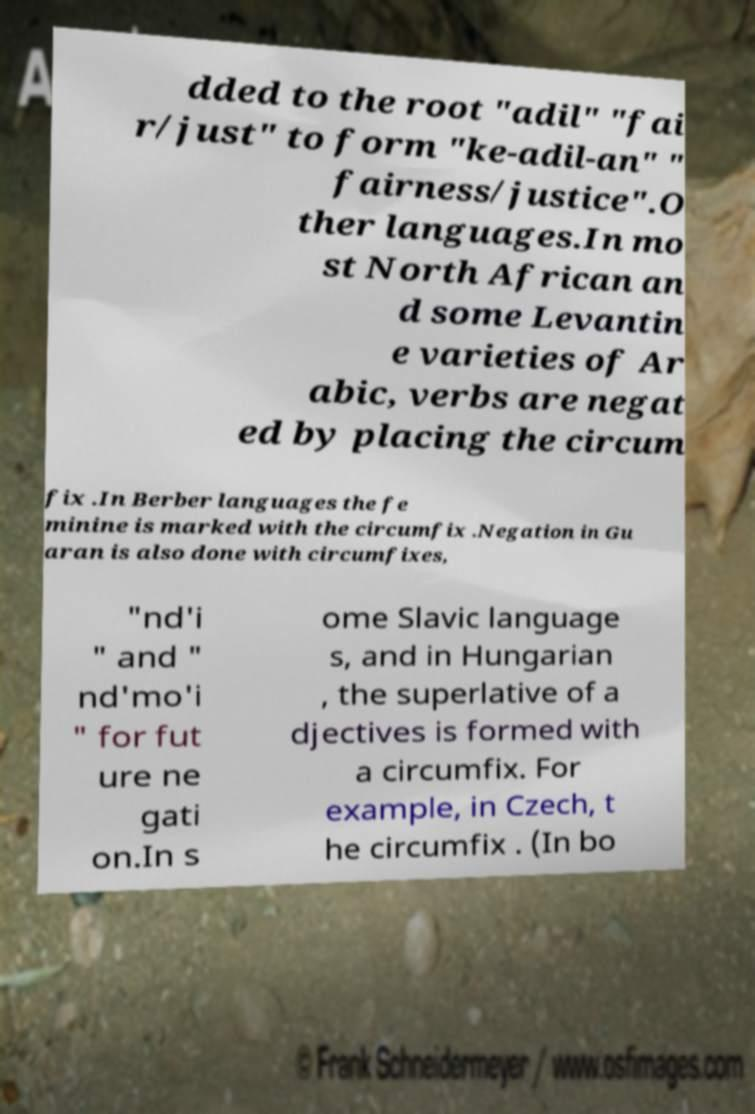Can you read and provide the text displayed in the image?This photo seems to have some interesting text. Can you extract and type it out for me? dded to the root "adil" "fai r/just" to form "ke-adil-an" " fairness/justice".O ther languages.In mo st North African an d some Levantin e varieties of Ar abic, verbs are negat ed by placing the circum fix .In Berber languages the fe minine is marked with the circumfix .Negation in Gu aran is also done with circumfixes, "nd'i " and " nd'mo'i " for fut ure ne gati on.In s ome Slavic language s, and in Hungarian , the superlative of a djectives is formed with a circumfix. For example, in Czech, t he circumfix . (In bo 